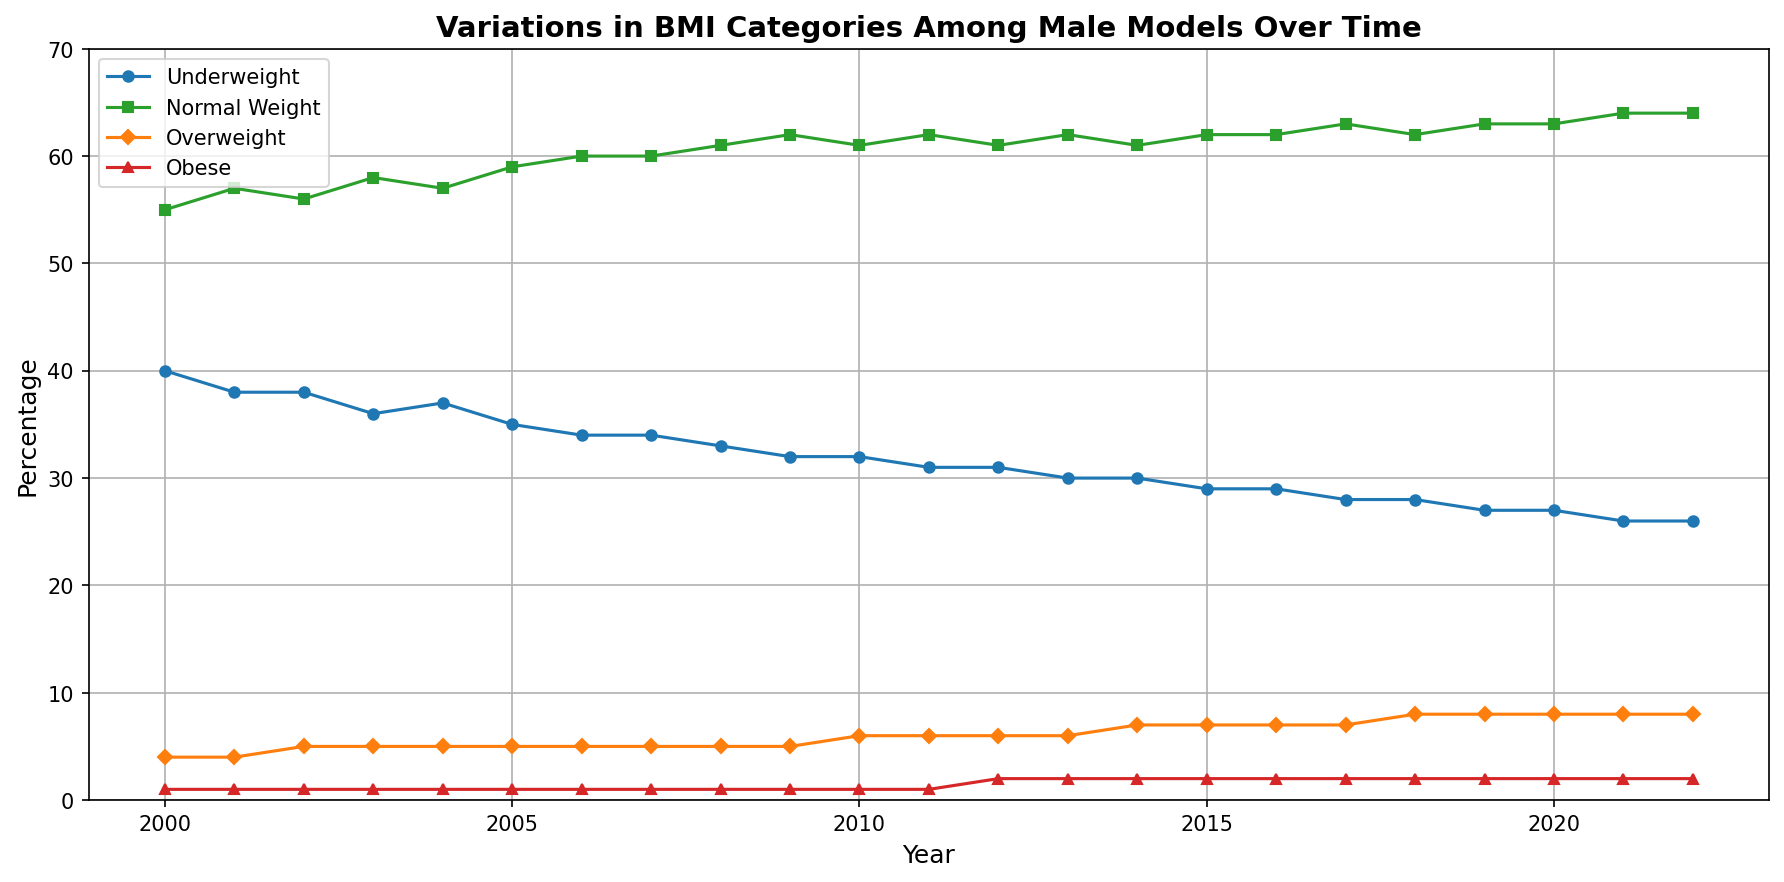What is the trend of underweight male models from 2000 to 2022? To understand the trend, observe the plot line for 'Underweight' (blue), which shows a general decrease over the years from 40% in 2000 to 26% in 2022. This indicates a downward trend.
Answer: Decreasing Which BMI category had the highest percentage in 2022? Look at the end of the plot lines for the year 2022. The 'Normal Weight' category (green) has the highest plot point at 64%.
Answer: Normal Weight In which year did the percentage of overweight male models first exceed 5%? Follow the 'Overweight' plot line (orange) and identify the year where it first exceeds 5%. This occurs in 2010 when the percentage reaches 6%.
Answer: 2010 How many points difference is there between underweight and normal weight male models in 2021? For 2021, the 'Underweight' category is at 26%, and the 'Normal Weight' category is at 64%. The difference between them is 64% - 26% = 38%.
Answer: 38% Compare the trend of obese male models to that of overweight male models from 2000 to 2022. The 'Obese' plot line (red) is relatively flat, increasing slightly from 1% to 2%. In contrast, the 'Overweight' plot line (orange) shows a gradual increase from 4% to 8%. The overweight trend is more pronounced than the obese trend.
Answer: Slight increase vs. gradual increase What visual element indicates the category for underweight male models? The 'Underweight' category is represented by a blue line with circle markers.
Answer: Blue line with circle markers 